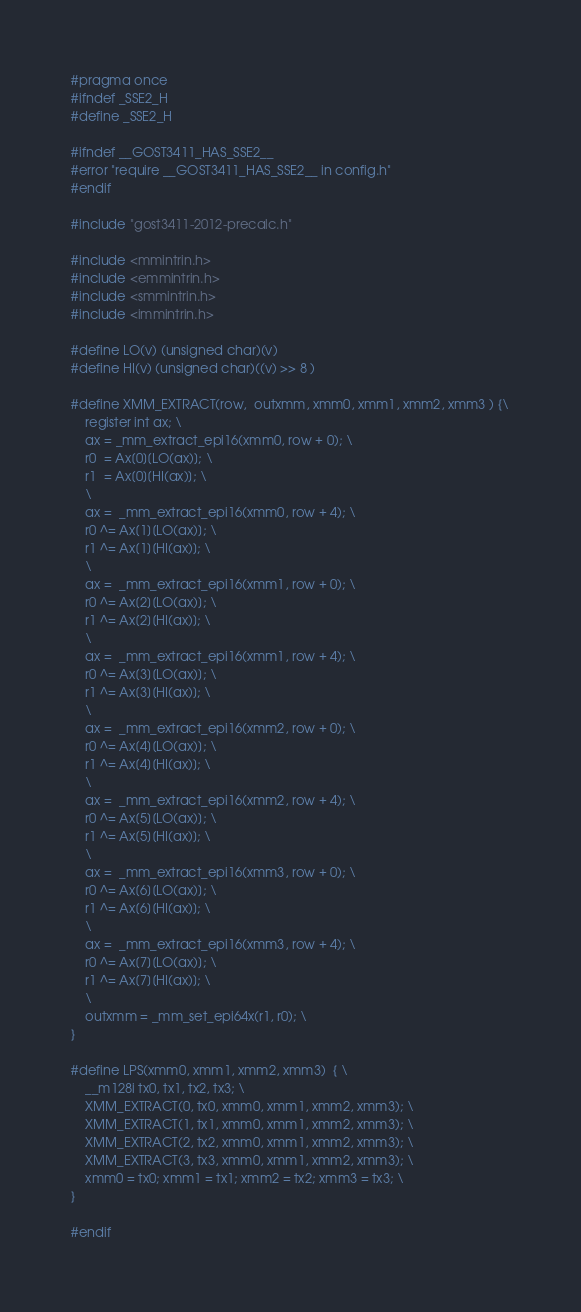<code> <loc_0><loc_0><loc_500><loc_500><_C_>#pragma once
#ifndef _SSE2_H
#define _SSE2_H

#ifndef __GOST3411_HAS_SSE2__
#error "require __GOST3411_HAS_SSE2__ in config.h"
#endif

#include "gost3411-2012-precalc.h"

#include <mmintrin.h>
#include <emmintrin.h>
#include <smmintrin.h>
#include <immintrin.h>

#define LO(v) (unsigned char)(v)
#define HI(v) (unsigned char)((v) >> 8 )

#define XMM_EXTRACT(row,  outxmm, xmm0, xmm1, xmm2, xmm3 ) {\
    register int ax; \
    ax = _mm_extract_epi16(xmm0, row + 0); \
    r0  = Ax[0][LO(ax)]; \
    r1  = Ax[0][HI(ax)]; \
    \
    ax =  _mm_extract_epi16(xmm0, row + 4); \
    r0 ^= Ax[1][LO(ax)]; \
    r1 ^= Ax[1][HI(ax)]; \
    \
    ax =  _mm_extract_epi16(xmm1, row + 0); \
    r0 ^= Ax[2][LO(ax)]; \
    r1 ^= Ax[2][HI(ax)]; \
    \
    ax =  _mm_extract_epi16(xmm1, row + 4); \
    r0 ^= Ax[3][LO(ax)]; \
    r1 ^= Ax[3][HI(ax)]; \
    \
    ax =  _mm_extract_epi16(xmm2, row + 0); \
    r0 ^= Ax[4][LO(ax)]; \
    r1 ^= Ax[4][HI(ax)]; \
    \
    ax =  _mm_extract_epi16(xmm2, row + 4); \
    r0 ^= Ax[5][LO(ax)]; \
    r1 ^= Ax[5][HI(ax)]; \
    \
    ax =  _mm_extract_epi16(xmm3, row + 0); \
    r0 ^= Ax[6][LO(ax)]; \
    r1 ^= Ax[6][HI(ax)]; \
    \
    ax =  _mm_extract_epi16(xmm3, row + 4); \
    r0 ^= Ax[7][LO(ax)]; \
    r1 ^= Ax[7][HI(ax)]; \
    \
    outxmm = _mm_set_epi64x(r1, r0); \
}

#define LPS(xmm0, xmm1, xmm2, xmm3)  { \
    __m128i tx0, tx1, tx2, tx3; \
    XMM_EXTRACT(0, tx0, xmm0, xmm1, xmm2, xmm3); \
    XMM_EXTRACT(1, tx1, xmm0, xmm1, xmm2, xmm3); \
    XMM_EXTRACT(2, tx2, xmm0, xmm1, xmm2, xmm3); \
    XMM_EXTRACT(3, tx3, xmm0, xmm1, xmm2, xmm3); \
    xmm0 = tx0; xmm1 = tx1; xmm2 = tx2; xmm3 = tx3; \
} 

#endif</code> 